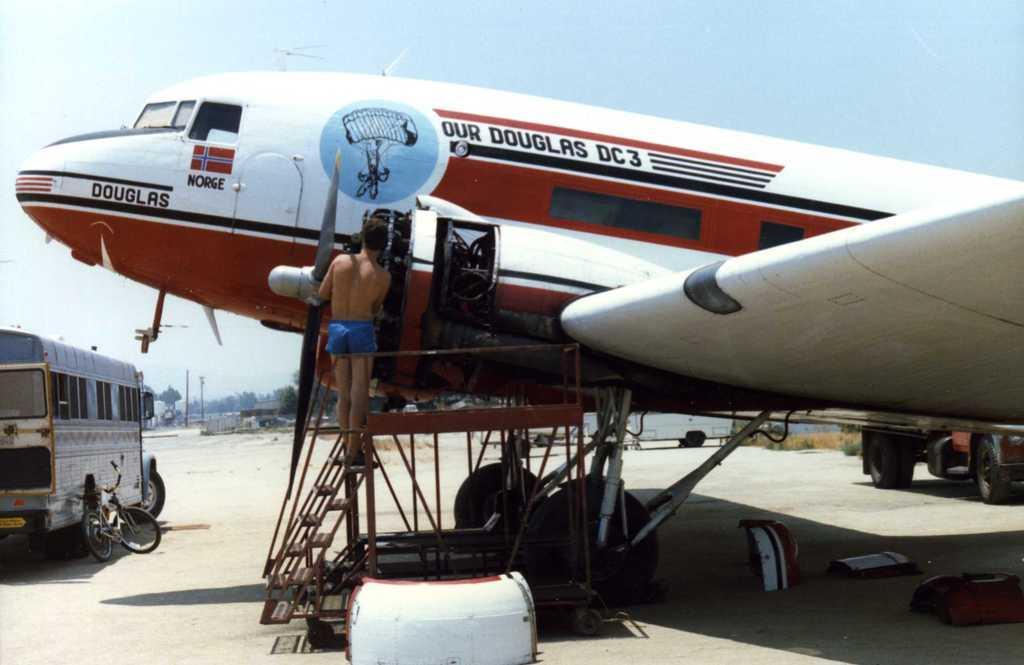Please provide a concise description of this image. In the center of the image there is an aeroplane and we can see a person standing on the stairs. There are vehicles. In the background we can see trees, poles and sky. 